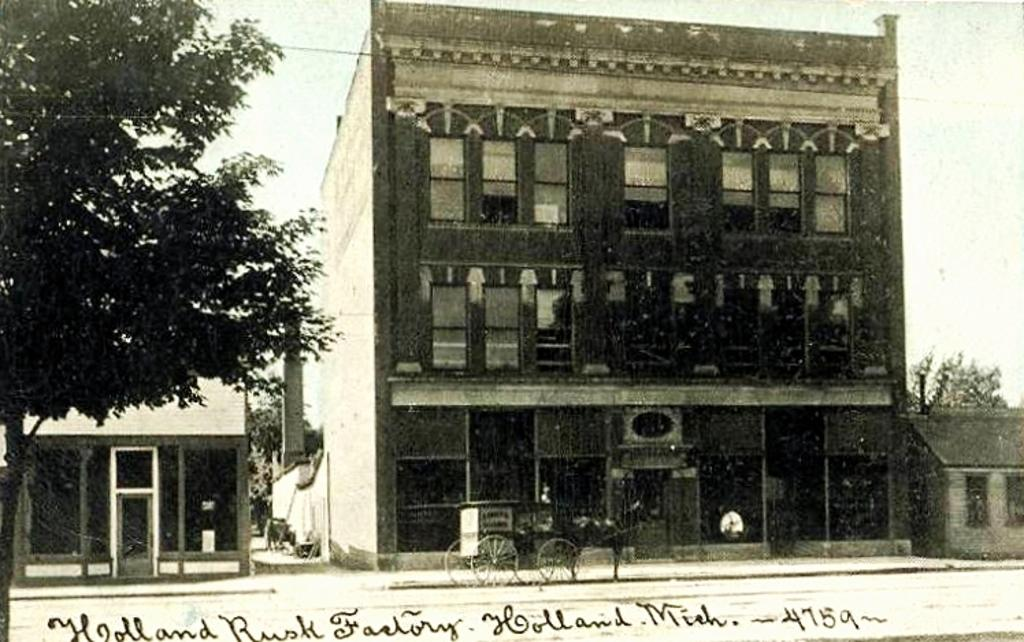What type of structures can be seen in the image? There are buildings in the image. What mode of transportation is present in the image? There is a horse cart in the image. What is visible in the background of the image? The sky is visible in the image. What type of infrastructure can be seen in the image? There are electric cables in the image. What type of natural elements are present in the image? Trees are present in the image. Where is the zoo located in the image? There is no zoo present in the image. What type of memory is stored in the horse cart? The horse cart is a mode of transportation and does not store memory. 